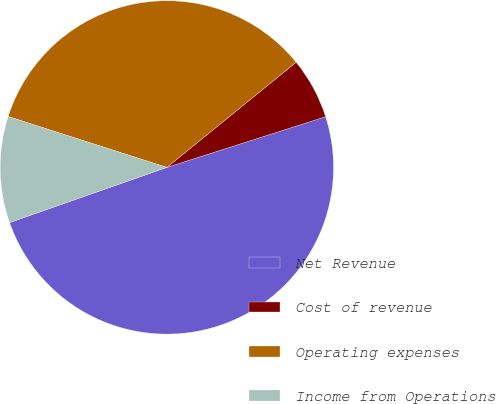Convert chart to OTSL. <chart><loc_0><loc_0><loc_500><loc_500><pie_chart><fcel>Net Revenue<fcel>Cost of revenue<fcel>Operating expenses<fcel>Income from Operations<nl><fcel>49.55%<fcel>5.95%<fcel>34.19%<fcel>10.31%<nl></chart> 